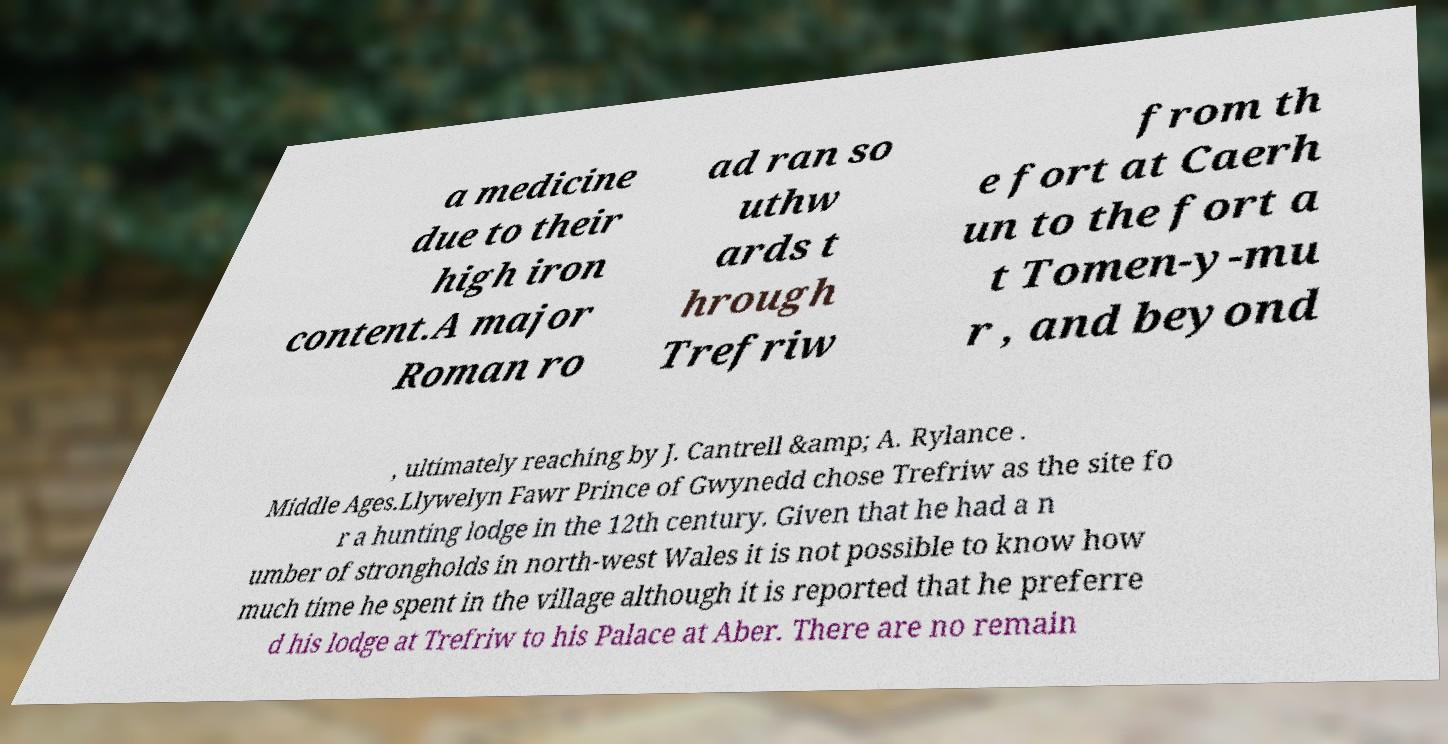I need the written content from this picture converted into text. Can you do that? a medicine due to their high iron content.A major Roman ro ad ran so uthw ards t hrough Trefriw from th e fort at Caerh un to the fort a t Tomen-y-mu r , and beyond , ultimately reaching by J. Cantrell &amp; A. Rylance . Middle Ages.Llywelyn Fawr Prince of Gwynedd chose Trefriw as the site fo r a hunting lodge in the 12th century. Given that he had a n umber of strongholds in north-west Wales it is not possible to know how much time he spent in the village although it is reported that he preferre d his lodge at Trefriw to his Palace at Aber. There are no remain 